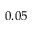<formula> <loc_0><loc_0><loc_500><loc_500>0 . 0 5</formula> 